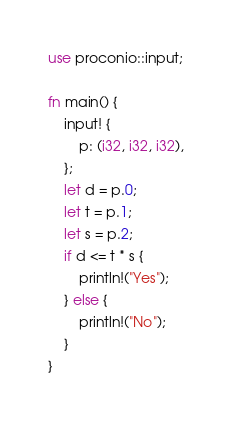Convert code to text. <code><loc_0><loc_0><loc_500><loc_500><_Rust_>use proconio::input;

fn main() {
    input! {
        p: (i32, i32, i32),
    };
    let d = p.0;
    let t = p.1;
    let s = p.2;
    if d <= t * s {
        println!("Yes");
    } else {
        println!("No");
    }
}
</code> 